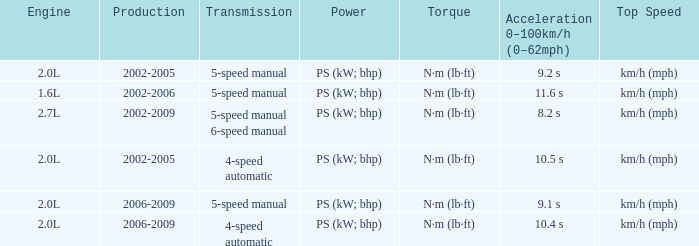What is the top speed of a 4-speed automatic with production in 2002-2005? Km/h (mph). 